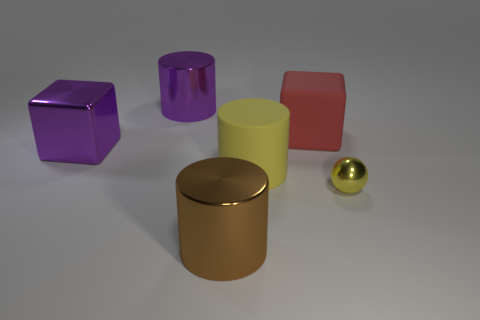Subtract all metallic cylinders. How many cylinders are left? 1 Add 1 big red rubber cylinders. How many objects exist? 7 Subtract all cubes. How many objects are left? 4 Subtract all purple cubes. How many cubes are left? 1 Subtract 3 cylinders. How many cylinders are left? 0 Subtract all purple blocks. Subtract all gray balls. How many blocks are left? 1 Subtract all yellow spheres. How many yellow cylinders are left? 1 Subtract all large brown shiny cylinders. Subtract all yellow metal balls. How many objects are left? 4 Add 2 big purple metallic things. How many big purple metallic things are left? 4 Add 4 large green rubber blocks. How many large green rubber blocks exist? 4 